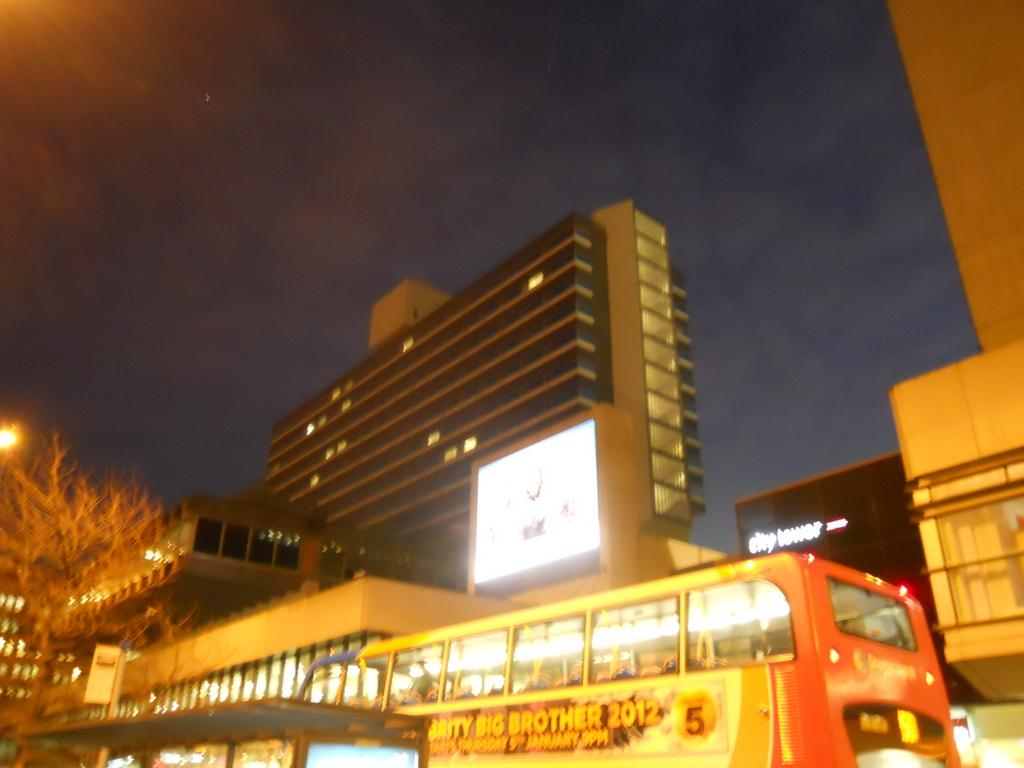What can be seen in the image besides the tree in the left bottom? There are vehicles and buildings visible in the image. Where are the buildings located in relation to the tree? The buildings are in the background of the image. What is visible at the top of the image? The sky is visible at the top of the image. What type of board provides comfort to the tree in the image? There is no board present in the image, and the tree does not require comfort. What sparks the interest of the vehicles in the image? There is no spark or interest mentioned in the image; the vehicles are simply parked or stationary. 